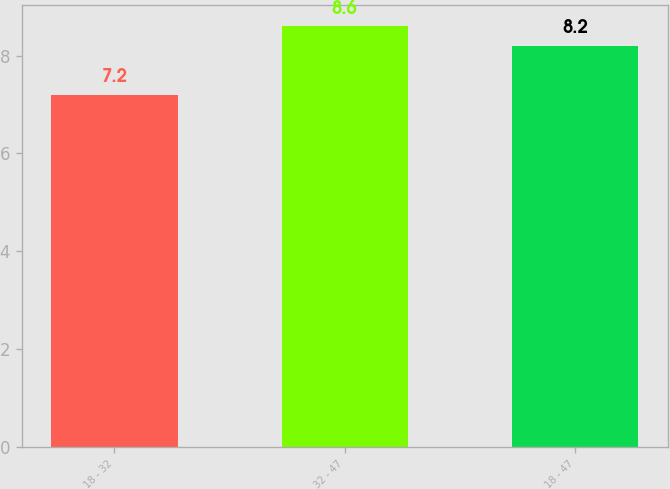Convert chart to OTSL. <chart><loc_0><loc_0><loc_500><loc_500><bar_chart><fcel>18 - 32<fcel>32 - 47<fcel>18 - 47<nl><fcel>7.2<fcel>8.6<fcel>8.2<nl></chart> 